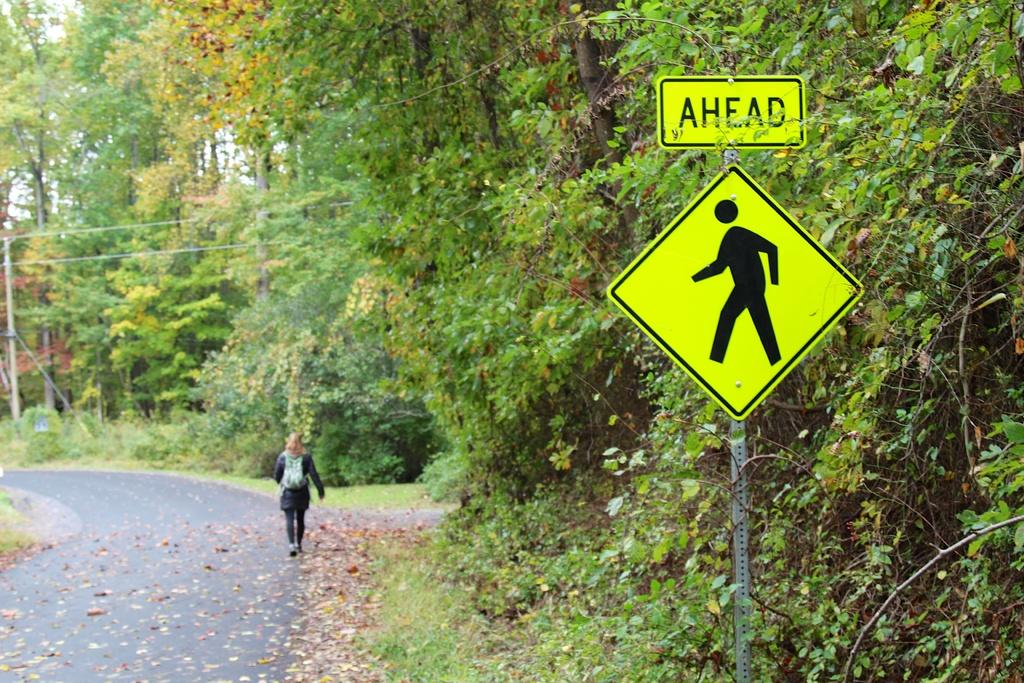<image>
Create a compact narrative representing the image presented. Street signs on silver pole in yellow rectangle with black lettering AHEAD and below it is a yellow square sign with black symbol of someone walking. 